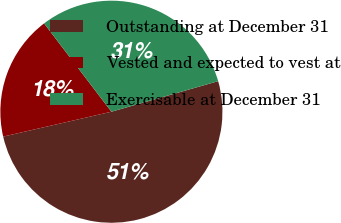<chart> <loc_0><loc_0><loc_500><loc_500><pie_chart><fcel>Outstanding at December 31<fcel>Vested and expected to vest at<fcel>Exercisable at December 31<nl><fcel>50.84%<fcel>18.23%<fcel>30.93%<nl></chart> 